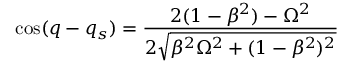Convert formula to latex. <formula><loc_0><loc_0><loc_500><loc_500>\cos ( q - q _ { s } ) = \frac { 2 ( 1 - \beta ^ { 2 } ) - \Omega ^ { 2 } } { 2 \sqrt { \beta ^ { 2 } \Omega ^ { 2 } + ( 1 - \beta ^ { 2 } ) ^ { 2 } } }</formula> 